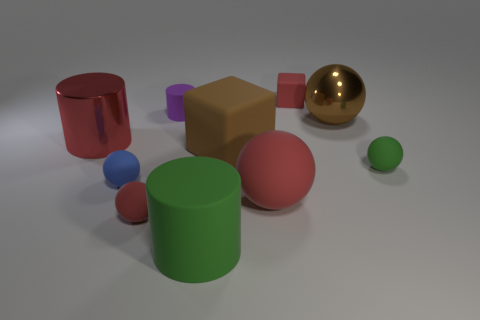Subtract all green rubber spheres. How many spheres are left? 4 Subtract all red blocks. How many blocks are left? 1 Subtract all cylinders. How many objects are left? 7 Subtract 2 blocks. How many blocks are left? 0 Subtract all yellow balls. Subtract all brown cubes. How many balls are left? 5 Subtract all blue spheres. How many yellow cylinders are left? 0 Subtract all blue rubber balls. Subtract all matte things. How many objects are left? 1 Add 9 large green cylinders. How many large green cylinders are left? 10 Add 7 small cyan balls. How many small cyan balls exist? 7 Subtract 0 green cubes. How many objects are left? 10 